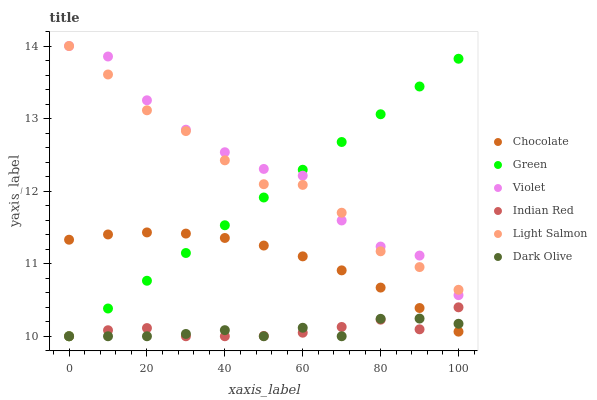Does Dark Olive have the minimum area under the curve?
Answer yes or no. Yes. Does Violet have the maximum area under the curve?
Answer yes or no. Yes. Does Chocolate have the minimum area under the curve?
Answer yes or no. No. Does Chocolate have the maximum area under the curve?
Answer yes or no. No. Is Green the smoothest?
Answer yes or no. Yes. Is Violet the roughest?
Answer yes or no. Yes. Is Dark Olive the smoothest?
Answer yes or no. No. Is Dark Olive the roughest?
Answer yes or no. No. Does Dark Olive have the lowest value?
Answer yes or no. Yes. Does Chocolate have the lowest value?
Answer yes or no. No. Does Violet have the highest value?
Answer yes or no. Yes. Does Chocolate have the highest value?
Answer yes or no. No. Is Indian Red less than Violet?
Answer yes or no. Yes. Is Violet greater than Chocolate?
Answer yes or no. Yes. Does Chocolate intersect Indian Red?
Answer yes or no. Yes. Is Chocolate less than Indian Red?
Answer yes or no. No. Is Chocolate greater than Indian Red?
Answer yes or no. No. Does Indian Red intersect Violet?
Answer yes or no. No. 